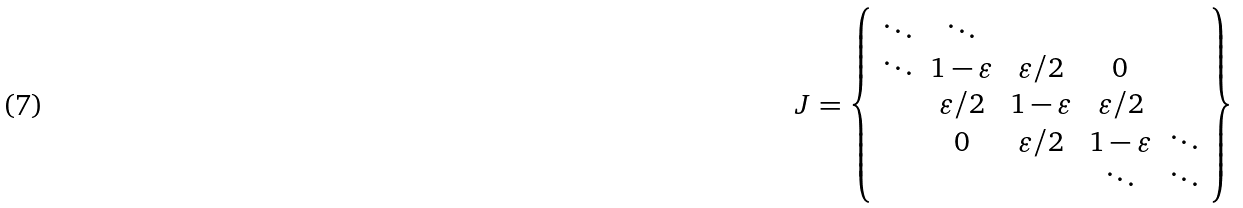<formula> <loc_0><loc_0><loc_500><loc_500>J = \left \{ \begin{array} { c c c c c } \ddots & \ddots \\ \ddots & 1 - \varepsilon & \varepsilon / 2 & 0 & \\ & \varepsilon / 2 & 1 - \varepsilon & \varepsilon / 2 & \\ & 0 & \varepsilon / 2 & 1 - \varepsilon & \ddots \\ & & & \ddots & \ddots \end{array} \right \}</formula> 